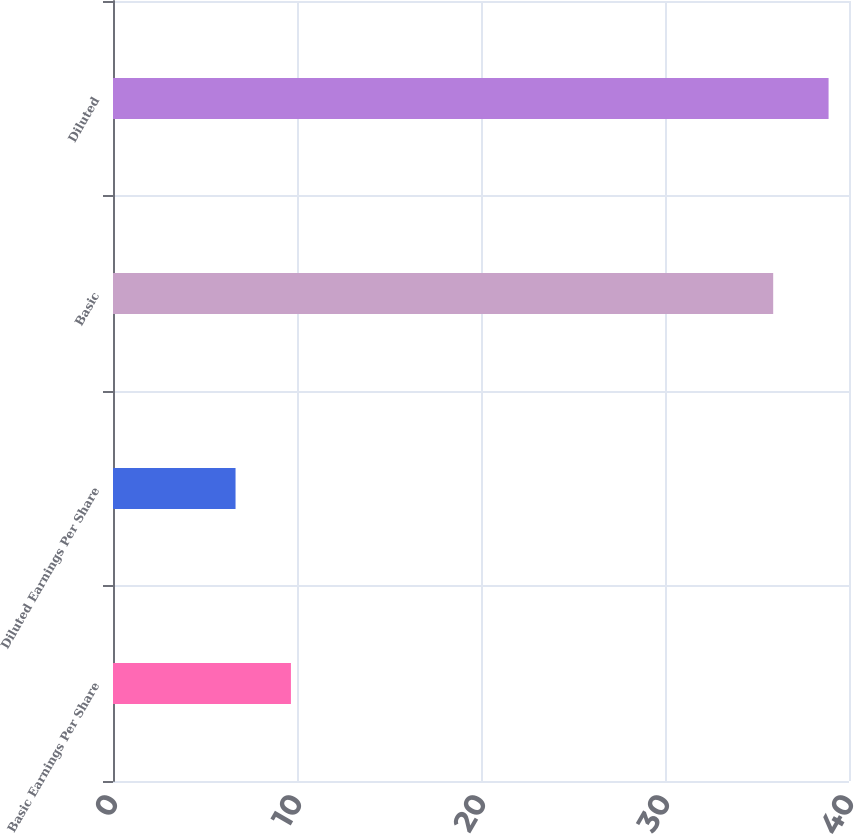Convert chart to OTSL. <chart><loc_0><loc_0><loc_500><loc_500><bar_chart><fcel>Basic Earnings Per Share<fcel>Diluted Earnings Per Share<fcel>Basic<fcel>Diluted<nl><fcel>9.67<fcel>6.66<fcel>35.88<fcel>38.89<nl></chart> 